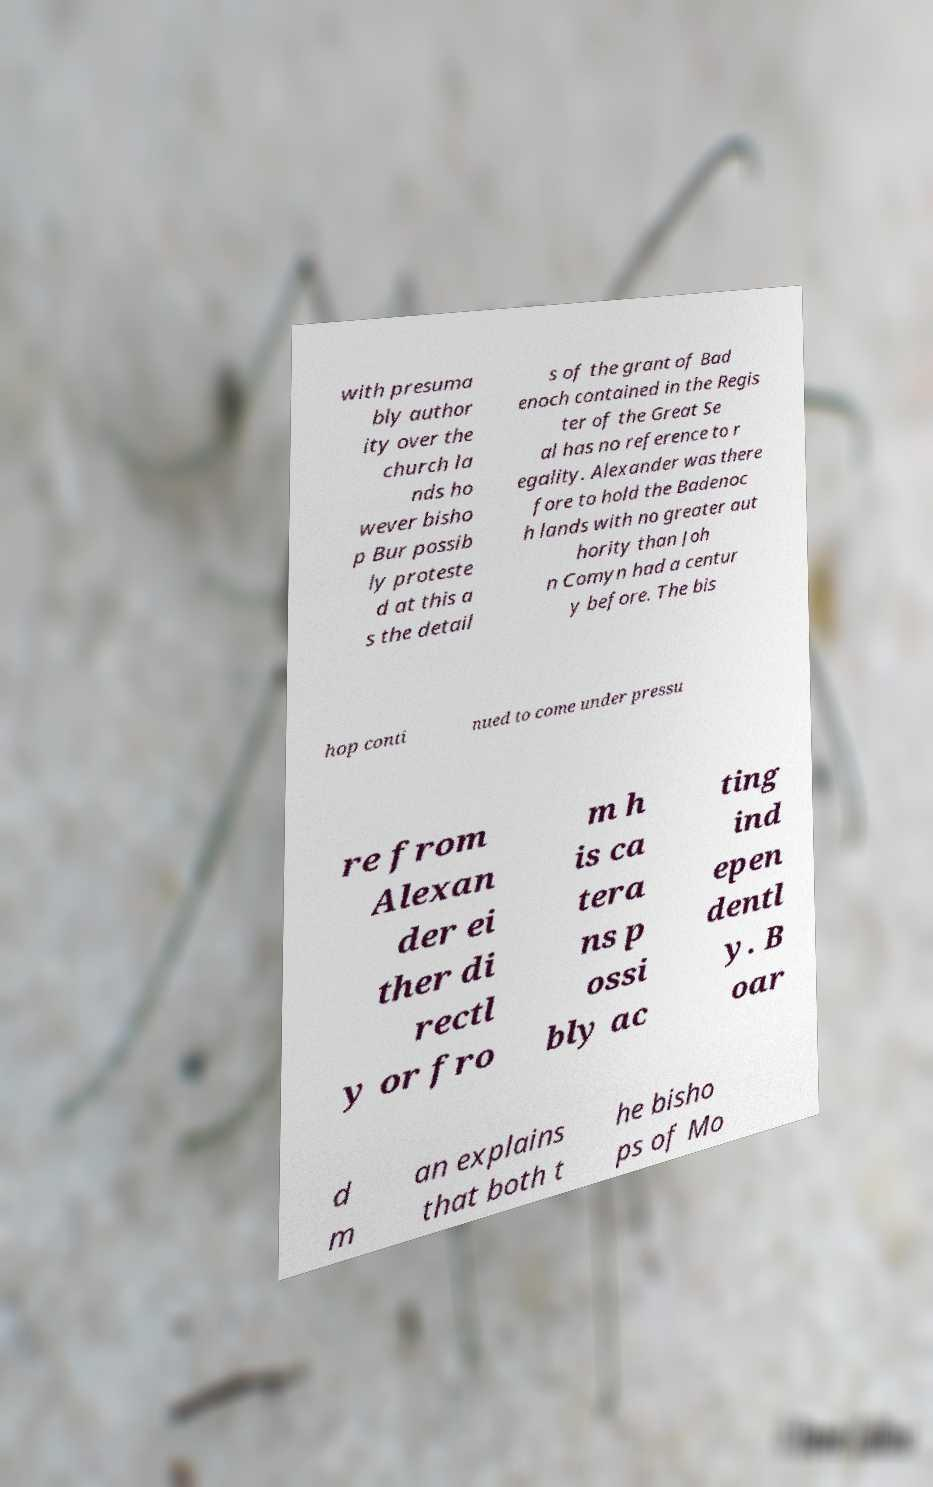Could you extract and type out the text from this image? with presuma bly author ity over the church la nds ho wever bisho p Bur possib ly proteste d at this a s the detail s of the grant of Bad enoch contained in the Regis ter of the Great Se al has no reference to r egality. Alexander was there fore to hold the Badenoc h lands with no greater aut hority than Joh n Comyn had a centur y before. The bis hop conti nued to come under pressu re from Alexan der ei ther di rectl y or fro m h is ca tera ns p ossi bly ac ting ind epen dentl y. B oar d m an explains that both t he bisho ps of Mo 